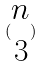<formula> <loc_0><loc_0><loc_500><loc_500>( \begin{matrix} n \\ 3 \end{matrix} )</formula> 